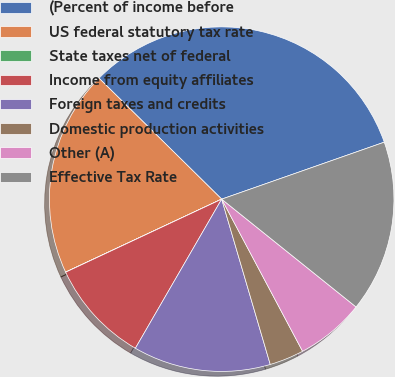<chart> <loc_0><loc_0><loc_500><loc_500><pie_chart><fcel>(Percent of income before<fcel>US federal statutory tax rate<fcel>State taxes net of federal<fcel>Income from equity affiliates<fcel>Foreign taxes and credits<fcel>Domestic production activities<fcel>Other (A)<fcel>Effective Tax Rate<nl><fcel>32.25%<fcel>19.35%<fcel>0.01%<fcel>9.68%<fcel>12.9%<fcel>3.23%<fcel>6.46%<fcel>16.13%<nl></chart> 